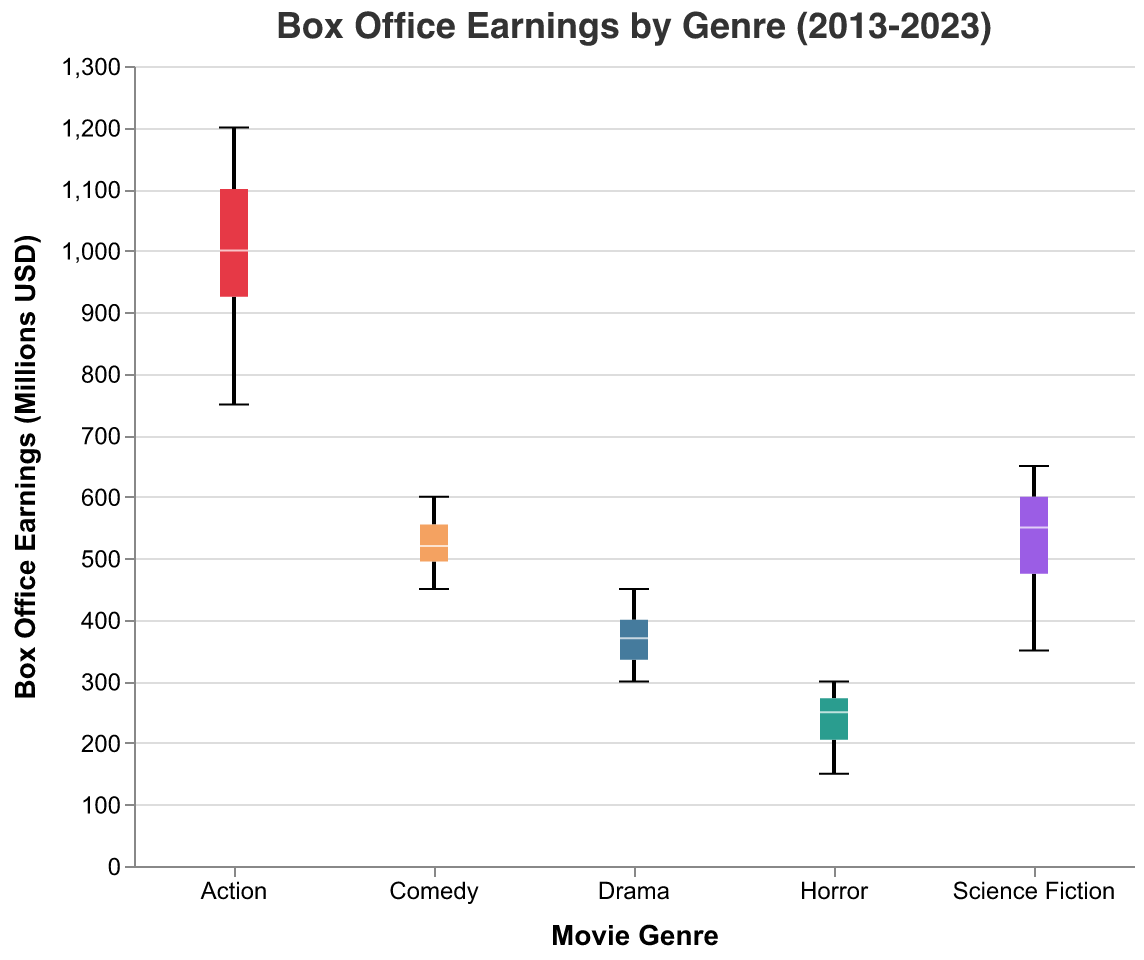What's the title of the figure? The title of the figure is displayed at the top and reads "Box Office Earnings by Genre (2013-2023)."
Answer: Box Office Earnings by Genre (2013-2023) What is the y-axis title? The y-axis title is labeled and positioned vertically; it reads "Box Office Earnings (Millions USD)."
Answer: Box Office Earnings (Millions USD) Which genre has the highest median box office earnings? To find the highest median, look at the middle line of each boxplot. The "Action" genre has the highest median box office earnings.
Answer: Action What is the interquartile range (IQR) for Comedy? The IQR can be found by looking at the length of the box in the boxplot. For Comedy, the IQR ranges from the lower quartile (around 480) to the upper quartile (around 570). Hence, the IQR is 570 - 480.
Answer: 90 Does any genre have outliers? Examine the boxplot for any dots outside the whiskers of the boxes. The "Action" genre has an outlier (750 in 2013).
Answer: Yes, Action Which genre experienced the lowest box office earnings between 2013 and 2023? The lowest box office earnings is indicated by the minimum point on each box plot. The "Horror" genre had the lowest earnings (150 in 2020).
Answer: Horror What is the range of box office earnings for Drama? Range is the difference between the maximum and minimum values. For Drama, it ranges from 300 (in 2013) to 450 (in 2019). Hence, 450 - 300.
Answer: 150 How do the maximum earnings of Science Fiction compare to those of Comedy? Look at the maximum values on both boxplots. Science Fiction has a maximum of 625 million USD (in 2023), and Comedy has a maximum of 600 million USD (in 2019). Thus, Science Fiction's maximum is higher.
Answer: Science Fiction is higher How did the Action genre earnings change over the decade? Investigate the Action genre's boxplot over time, noticing that it started lower and increased significantly over the decade, peaking around 2023.
Answer: Increased overall Which genre shows the most consistency in box office earnings? Consistency can be inferred from the smallest IQR and range. Drama has smaller variations between its earnings, reflected by a narrow box and close whiskers.
Answer: Drama 